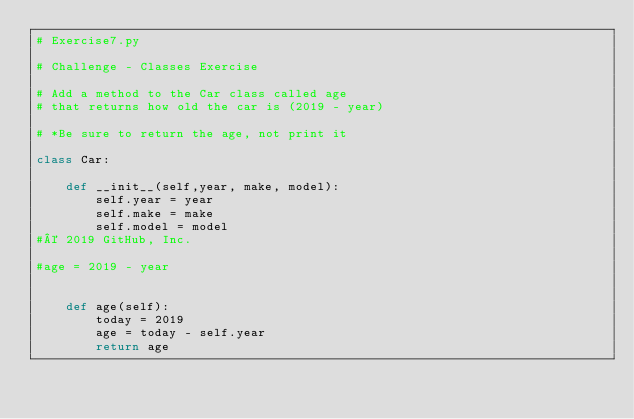<code> <loc_0><loc_0><loc_500><loc_500><_Python_># Exercise7.py

# Challenge - Classes Exercise

# Add a method to the Car class called age
# that returns how old the car is (2019 - year)

# *Be sure to return the age, not print it

class Car:

    def __init__(self,year, make, model):
        self.year = year
        self.make = make
        self.model = model
#© 2019 GitHub, Inc.

#age = 2019 - year


	def age(self):
        today = 2019
        age = today - self.year
        return age
</code> 